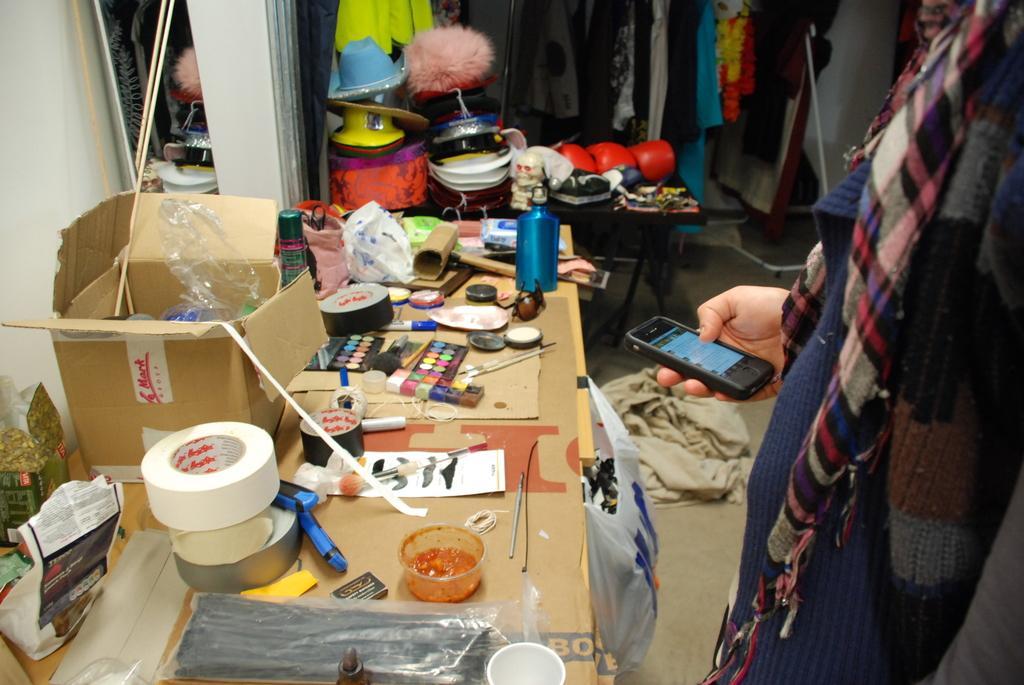Please provide a concise description of this image. In the image we can see there is a person standing and he is holding mobile phone in his hand. There are clothes kept in the hanger and there are other items kept on the table. There are tapes, colour palette and water bottle kept on the table. 